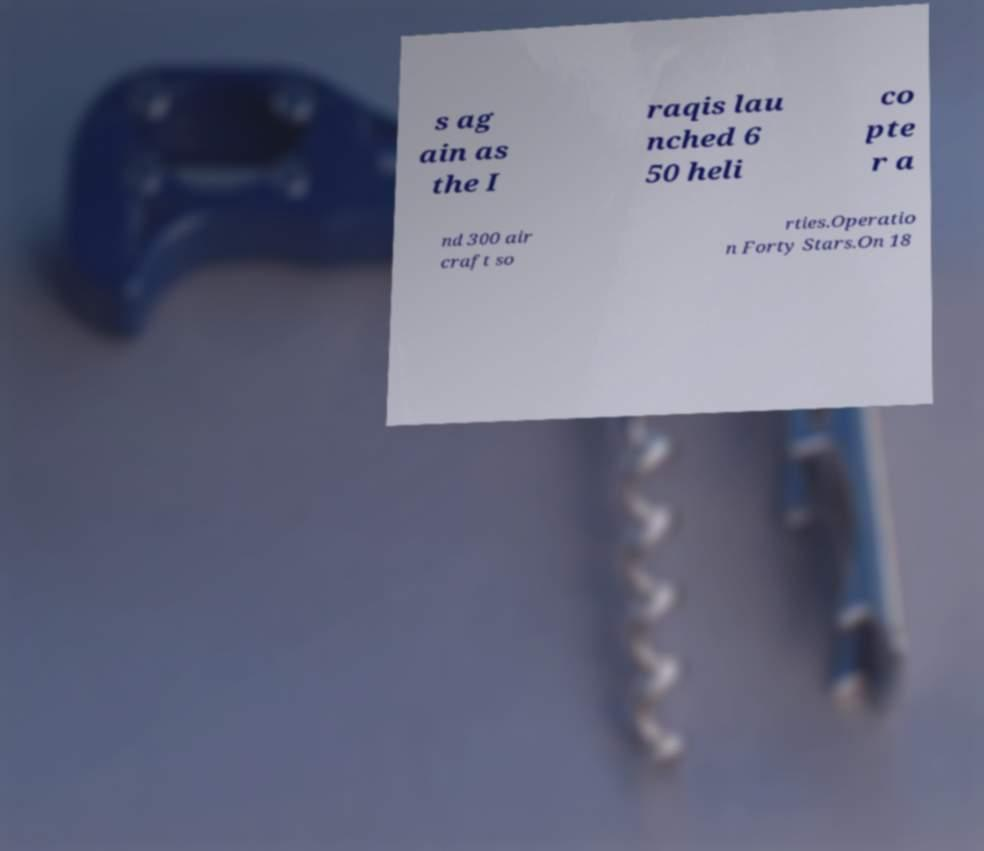For documentation purposes, I need the text within this image transcribed. Could you provide that? s ag ain as the I raqis lau nched 6 50 heli co pte r a nd 300 air craft so rties.Operatio n Forty Stars.On 18 